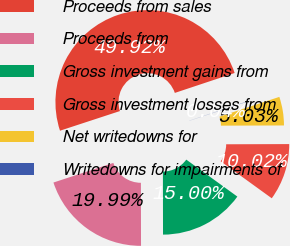Convert chart to OTSL. <chart><loc_0><loc_0><loc_500><loc_500><pie_chart><fcel>Proceeds from sales<fcel>Proceeds from<fcel>Gross investment gains from<fcel>Gross investment losses from<fcel>Net writedowns for<fcel>Writedowns for impairments of<nl><fcel>49.92%<fcel>19.99%<fcel>15.0%<fcel>10.02%<fcel>5.03%<fcel>0.04%<nl></chart> 